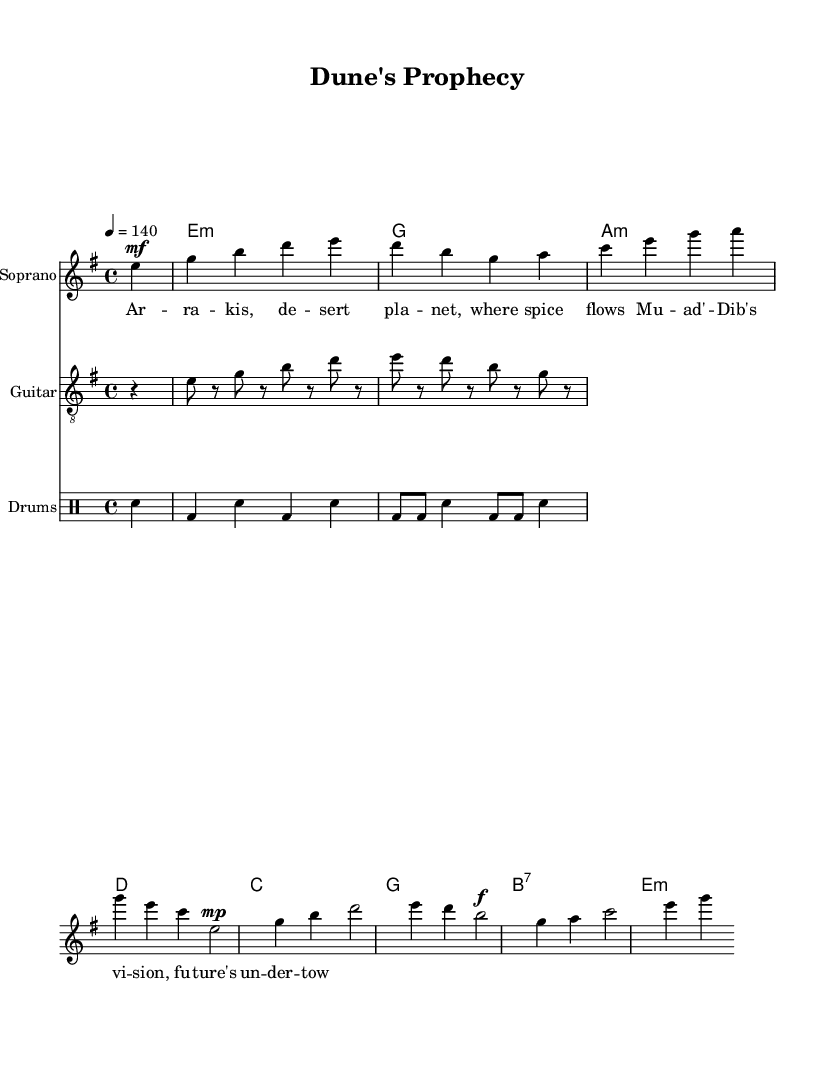What is the key signature of this music? The key signature is E minor, which has one sharp (F#). This can be identified in the sheet music where the sharp is notated at the beginning of the staff.
Answer: E minor What is the time signature of this music? The time signature is 4/4, indicated at the beginning of the score as '4/4', meaning there are four beats in a measure.
Answer: 4/4 What is the tempo marking for this piece? The tempo marking is 140 beats per minute, shown as '4 = 140' in the tempo directive at the start of the score.
Answer: 140 What motif appears prominently in the soprano part? The motif that appears is based on the note E, as it is frequently repeated throughout the soprano line, starting on the first note and appearing multiple times in the melody.
Answer: E What is the dynamic marking for the first soprano phrase? The dynamic marking is mezzo-forte (mf), indicated right after the first note, suggesting that this section should be played moderately loud.
Answer: mezzo-forte How does the guitar riff relate to the overall style of symphonic metal? The guitar riff emphasizes rhythmic energy and incorporates syncopation, typical in symphonic metal to enhance the dramatic and operatic nature, fitting the context of the powerful themes of the piece.
Answer: Syncopated rhythm 